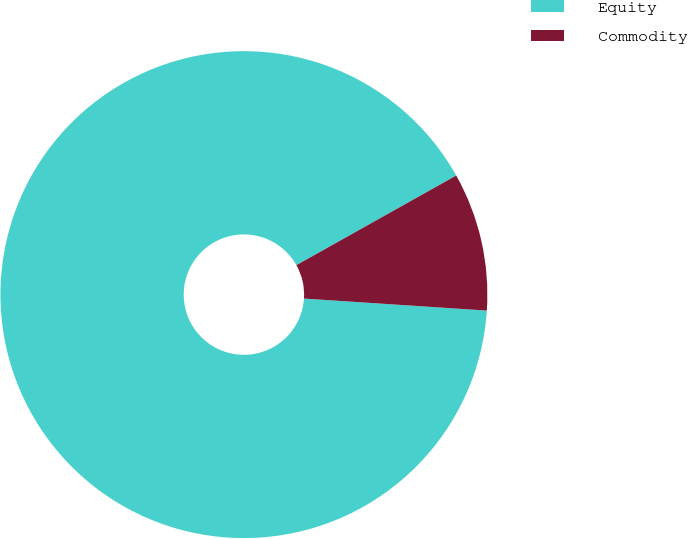<chart> <loc_0><loc_0><loc_500><loc_500><pie_chart><fcel>Equity<fcel>Commodity<nl><fcel>90.82%<fcel>9.18%<nl></chart> 